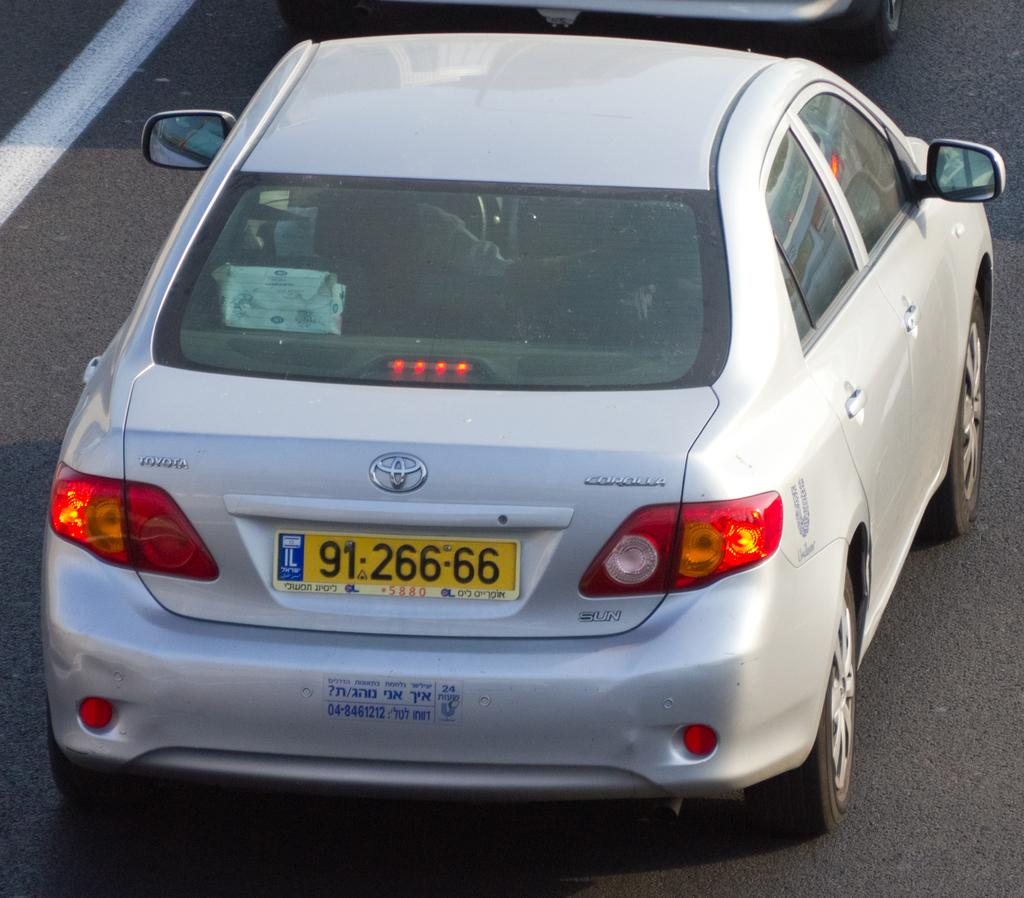<image>
Summarize the visual content of the image. A silver Toyota with the license plate 91 266-66. 